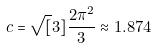<formula> <loc_0><loc_0><loc_500><loc_500>c = \sqrt { [ } 3 ] { \frac { 2 \pi ^ { 2 } } { 3 } } \approx 1 . 8 7 4</formula> 